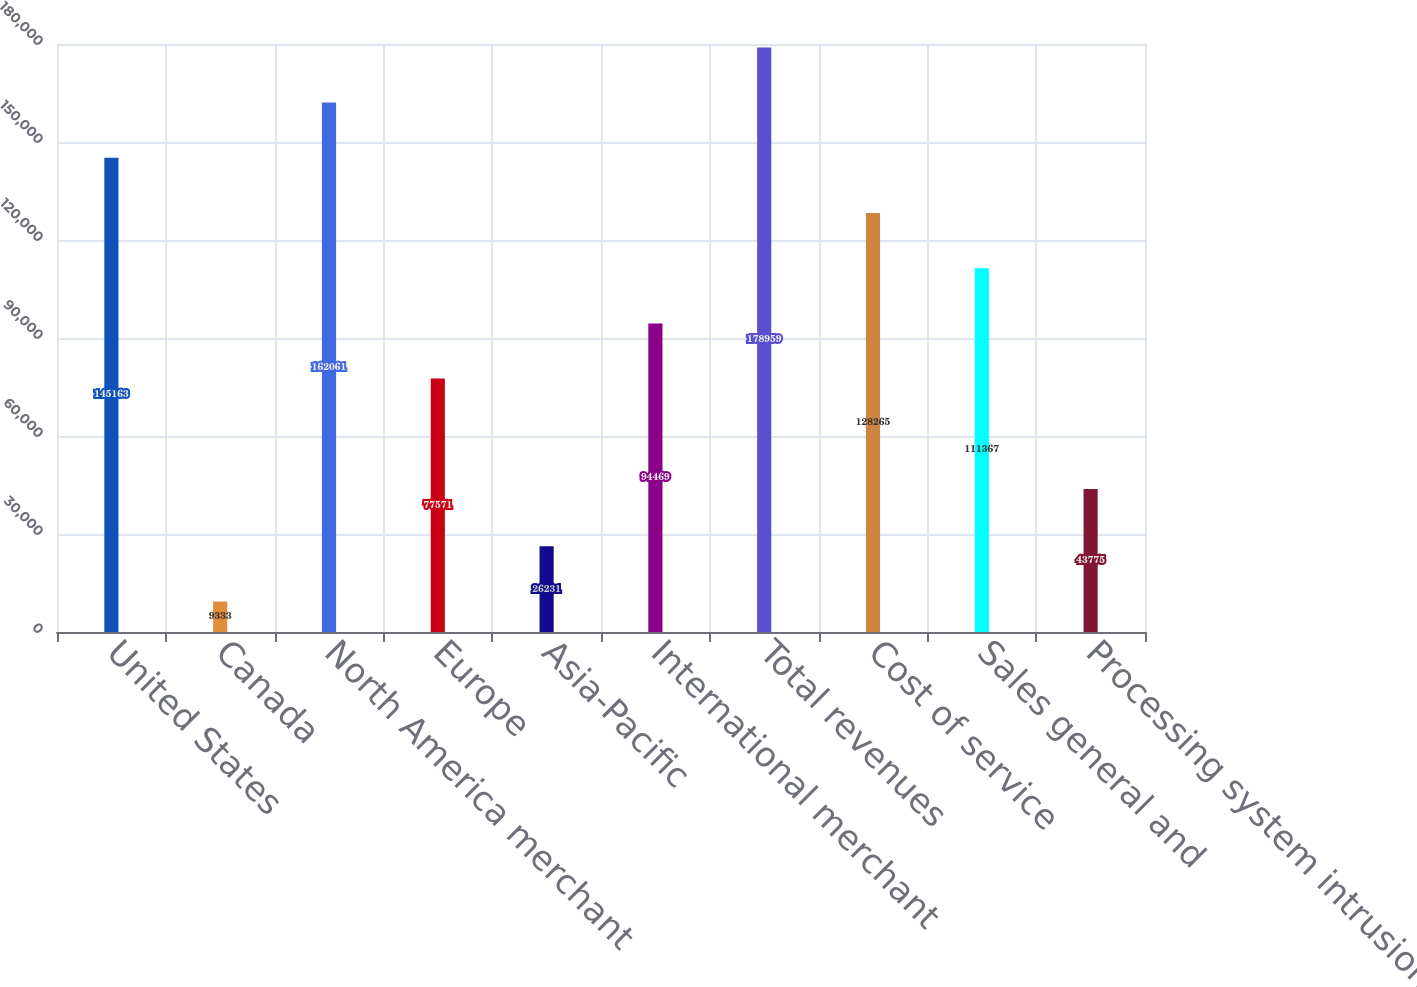<chart> <loc_0><loc_0><loc_500><loc_500><bar_chart><fcel>United States<fcel>Canada<fcel>North America merchant<fcel>Europe<fcel>Asia-Pacific<fcel>International merchant<fcel>Total revenues<fcel>Cost of service<fcel>Sales general and<fcel>Processing system intrusion<nl><fcel>145163<fcel>9333<fcel>162061<fcel>77571<fcel>26231<fcel>94469<fcel>178959<fcel>128265<fcel>111367<fcel>43775<nl></chart> 